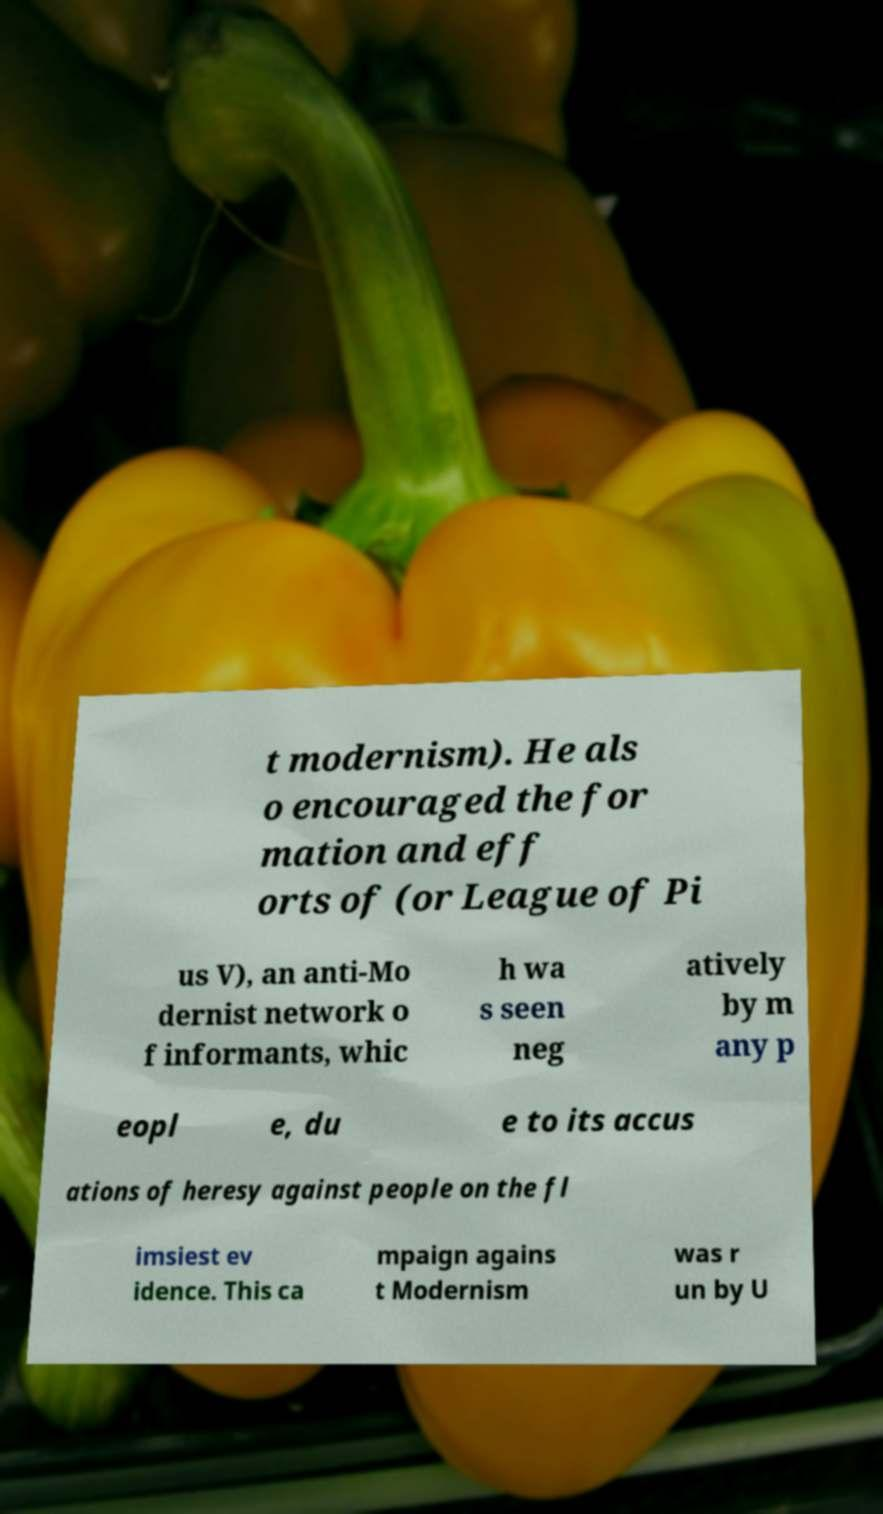Could you extract and type out the text from this image? t modernism). He als o encouraged the for mation and eff orts of (or League of Pi us V), an anti-Mo dernist network o f informants, whic h wa s seen neg atively by m any p eopl e, du e to its accus ations of heresy against people on the fl imsiest ev idence. This ca mpaign agains t Modernism was r un by U 